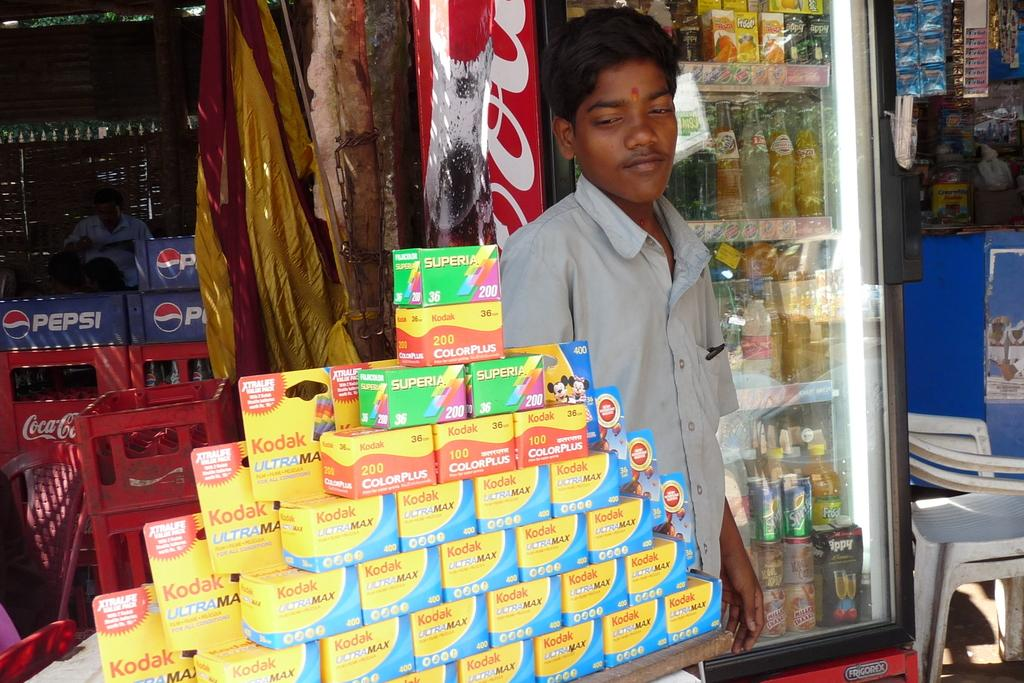<image>
Summarize the visual content of the image. a man is standing behind a display of kodak film 